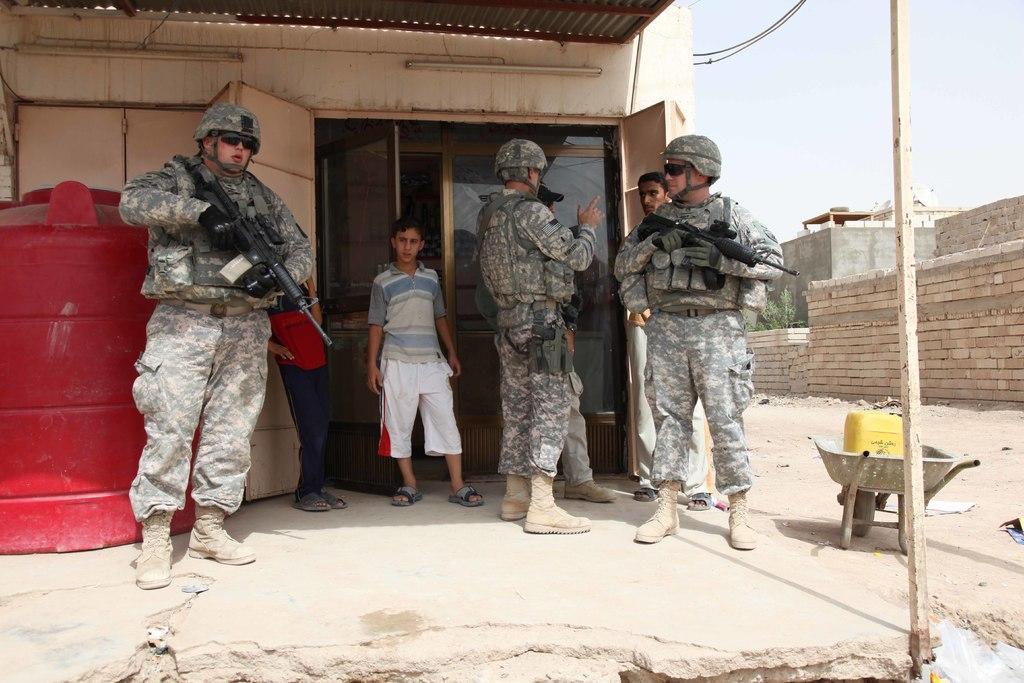Describe this image in one or two sentences. This image is taken outdoors. At the bottom of the image there is a floor and a ground. In the background there is a room with walls and a door. In the middle of the image a few people are standing on the ground and holding guns in their hands. On the left side of the image there is a tank. On the right side of the image there are a few bricks and a house and there is a trolley on the ground. At the top of the image there is a sky. 